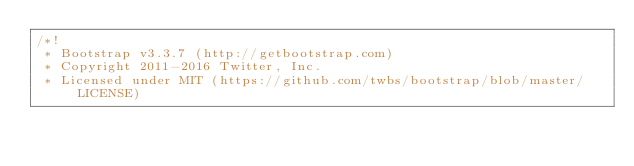<code> <loc_0><loc_0><loc_500><loc_500><_CSS_>/*!
 * Bootstrap v3.3.7 (http://getbootstrap.com)
 * Copyright 2011-2016 Twitter, Inc.
 * Licensed under MIT (https://github.com/twbs/bootstrap/blob/master/LICENSE)</code> 